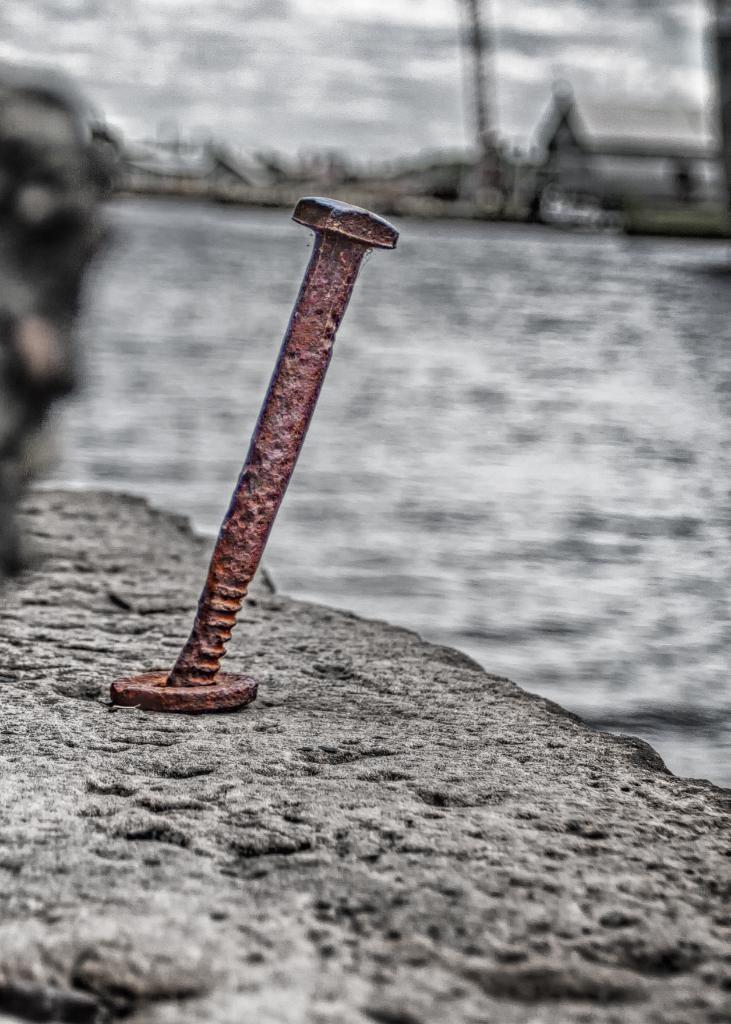What type of object can be seen in the image? There is an iron object in the image. Can you describe the background of the image? The background of the image is blurred. What type of wool is being used to create the reward in the image? There is no wool or reward present in the image; it only features an iron object with a blurred background. 